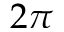Convert formula to latex. <formula><loc_0><loc_0><loc_500><loc_500>2 \pi</formula> 